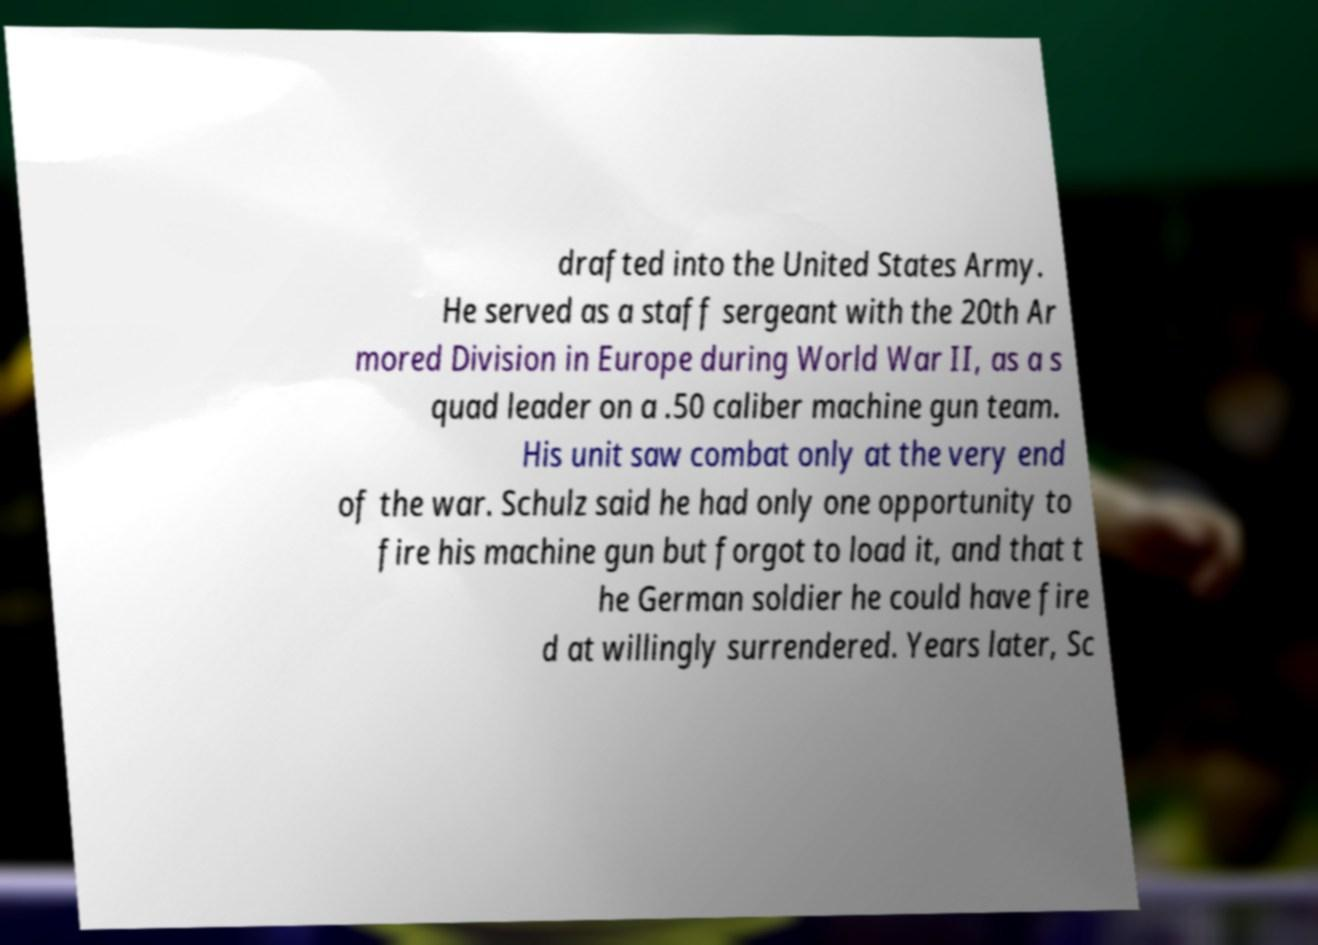Please identify and transcribe the text found in this image. drafted into the United States Army. He served as a staff sergeant with the 20th Ar mored Division in Europe during World War II, as a s quad leader on a .50 caliber machine gun team. His unit saw combat only at the very end of the war. Schulz said he had only one opportunity to fire his machine gun but forgot to load it, and that t he German soldier he could have fire d at willingly surrendered. Years later, Sc 